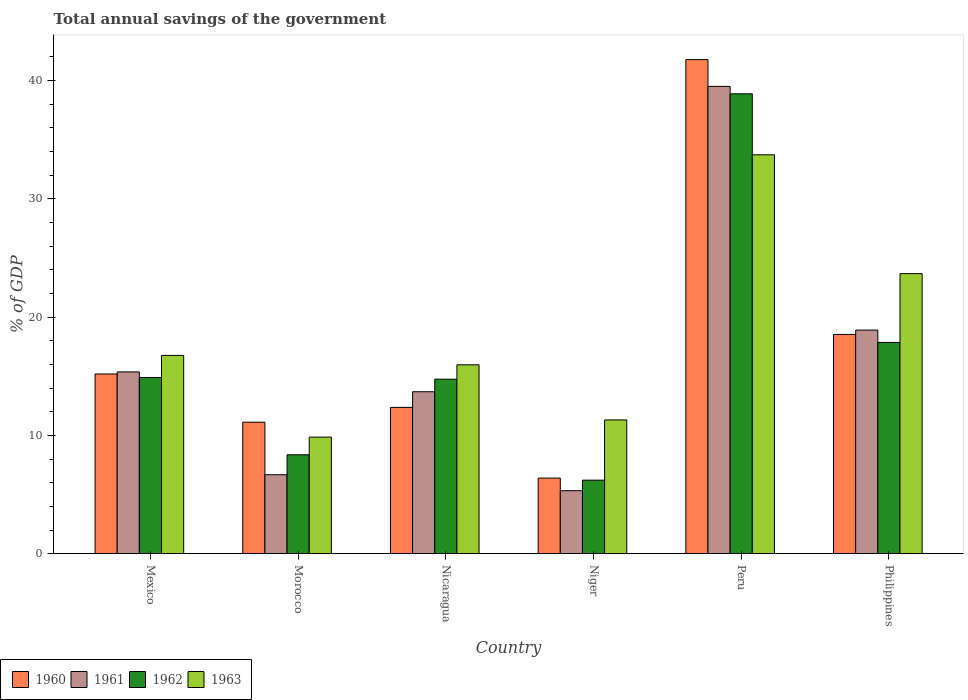How many different coloured bars are there?
Keep it short and to the point. 4. How many groups of bars are there?
Your response must be concise. 6. Are the number of bars per tick equal to the number of legend labels?
Ensure brevity in your answer.  Yes. Are the number of bars on each tick of the X-axis equal?
Ensure brevity in your answer.  Yes. How many bars are there on the 2nd tick from the left?
Offer a terse response. 4. How many bars are there on the 1st tick from the right?
Offer a very short reply. 4. What is the total annual savings of the government in 1961 in Niger?
Your answer should be compact. 5.32. Across all countries, what is the maximum total annual savings of the government in 1961?
Give a very brief answer. 39.51. Across all countries, what is the minimum total annual savings of the government in 1963?
Your answer should be very brief. 9.85. In which country was the total annual savings of the government in 1962 minimum?
Keep it short and to the point. Niger. What is the total total annual savings of the government in 1962 in the graph?
Your response must be concise. 100.96. What is the difference between the total annual savings of the government in 1962 in Nicaragua and that in Niger?
Give a very brief answer. 8.54. What is the difference between the total annual savings of the government in 1963 in Mexico and the total annual savings of the government in 1961 in Philippines?
Give a very brief answer. -2.14. What is the average total annual savings of the government in 1962 per country?
Provide a short and direct response. 16.83. What is the difference between the total annual savings of the government of/in 1960 and total annual savings of the government of/in 1963 in Nicaragua?
Keep it short and to the point. -3.6. What is the ratio of the total annual savings of the government in 1961 in Nicaragua to that in Philippines?
Offer a terse response. 0.72. What is the difference between the highest and the second highest total annual savings of the government in 1961?
Give a very brief answer. 3.54. What is the difference between the highest and the lowest total annual savings of the government in 1963?
Provide a short and direct response. 23.87. Is it the case that in every country, the sum of the total annual savings of the government in 1961 and total annual savings of the government in 1962 is greater than the sum of total annual savings of the government in 1963 and total annual savings of the government in 1960?
Your answer should be very brief. No. What does the 2nd bar from the left in Peru represents?
Your response must be concise. 1961. Is it the case that in every country, the sum of the total annual savings of the government in 1961 and total annual savings of the government in 1960 is greater than the total annual savings of the government in 1963?
Keep it short and to the point. Yes. How many countries are there in the graph?
Your response must be concise. 6. Where does the legend appear in the graph?
Keep it short and to the point. Bottom left. How many legend labels are there?
Ensure brevity in your answer.  4. What is the title of the graph?
Offer a very short reply. Total annual savings of the government. What is the label or title of the Y-axis?
Provide a short and direct response. % of GDP. What is the % of GDP in 1960 in Mexico?
Keep it short and to the point. 15.19. What is the % of GDP of 1961 in Mexico?
Ensure brevity in your answer.  15.37. What is the % of GDP in 1962 in Mexico?
Keep it short and to the point. 14.89. What is the % of GDP of 1963 in Mexico?
Offer a very short reply. 16.76. What is the % of GDP in 1960 in Morocco?
Ensure brevity in your answer.  11.12. What is the % of GDP of 1961 in Morocco?
Give a very brief answer. 6.67. What is the % of GDP in 1962 in Morocco?
Your answer should be very brief. 8.36. What is the % of GDP in 1963 in Morocco?
Provide a succinct answer. 9.85. What is the % of GDP in 1960 in Nicaragua?
Provide a short and direct response. 12.37. What is the % of GDP in 1961 in Nicaragua?
Your response must be concise. 13.69. What is the % of GDP in 1962 in Nicaragua?
Provide a succinct answer. 14.75. What is the % of GDP of 1963 in Nicaragua?
Your response must be concise. 15.97. What is the % of GDP in 1960 in Niger?
Keep it short and to the point. 6.39. What is the % of GDP in 1961 in Niger?
Your response must be concise. 5.32. What is the % of GDP in 1962 in Niger?
Your response must be concise. 6.21. What is the % of GDP in 1963 in Niger?
Keep it short and to the point. 11.31. What is the % of GDP of 1960 in Peru?
Offer a terse response. 41.78. What is the % of GDP of 1961 in Peru?
Keep it short and to the point. 39.51. What is the % of GDP of 1962 in Peru?
Give a very brief answer. 38.88. What is the % of GDP in 1963 in Peru?
Make the answer very short. 33.73. What is the % of GDP of 1960 in Philippines?
Provide a short and direct response. 18.54. What is the % of GDP in 1961 in Philippines?
Your answer should be compact. 18.9. What is the % of GDP of 1962 in Philippines?
Offer a terse response. 17.86. What is the % of GDP in 1963 in Philippines?
Provide a short and direct response. 23.68. Across all countries, what is the maximum % of GDP of 1960?
Provide a short and direct response. 41.78. Across all countries, what is the maximum % of GDP in 1961?
Give a very brief answer. 39.51. Across all countries, what is the maximum % of GDP in 1962?
Your answer should be very brief. 38.88. Across all countries, what is the maximum % of GDP of 1963?
Offer a very short reply. 33.73. Across all countries, what is the minimum % of GDP of 1960?
Your response must be concise. 6.39. Across all countries, what is the minimum % of GDP in 1961?
Offer a very short reply. 5.32. Across all countries, what is the minimum % of GDP in 1962?
Offer a terse response. 6.21. Across all countries, what is the minimum % of GDP in 1963?
Your answer should be very brief. 9.85. What is the total % of GDP of 1960 in the graph?
Make the answer very short. 105.38. What is the total % of GDP of 1961 in the graph?
Offer a terse response. 99.46. What is the total % of GDP in 1962 in the graph?
Keep it short and to the point. 100.96. What is the total % of GDP in 1963 in the graph?
Provide a succinct answer. 111.3. What is the difference between the % of GDP of 1960 in Mexico and that in Morocco?
Your answer should be very brief. 4.08. What is the difference between the % of GDP in 1961 in Mexico and that in Morocco?
Your answer should be very brief. 8.7. What is the difference between the % of GDP in 1962 in Mexico and that in Morocco?
Provide a short and direct response. 6.53. What is the difference between the % of GDP of 1963 in Mexico and that in Morocco?
Ensure brevity in your answer.  6.91. What is the difference between the % of GDP in 1960 in Mexico and that in Nicaragua?
Your answer should be compact. 2.82. What is the difference between the % of GDP in 1961 in Mexico and that in Nicaragua?
Your answer should be very brief. 1.68. What is the difference between the % of GDP of 1962 in Mexico and that in Nicaragua?
Offer a very short reply. 0.14. What is the difference between the % of GDP of 1963 in Mexico and that in Nicaragua?
Keep it short and to the point. 0.8. What is the difference between the % of GDP in 1960 in Mexico and that in Niger?
Offer a very short reply. 8.8. What is the difference between the % of GDP of 1961 in Mexico and that in Niger?
Ensure brevity in your answer.  10.04. What is the difference between the % of GDP of 1962 in Mexico and that in Niger?
Offer a very short reply. 8.68. What is the difference between the % of GDP in 1963 in Mexico and that in Niger?
Offer a very short reply. 5.46. What is the difference between the % of GDP in 1960 in Mexico and that in Peru?
Offer a very short reply. -26.58. What is the difference between the % of GDP of 1961 in Mexico and that in Peru?
Offer a very short reply. -24.14. What is the difference between the % of GDP in 1962 in Mexico and that in Peru?
Your response must be concise. -23.99. What is the difference between the % of GDP in 1963 in Mexico and that in Peru?
Make the answer very short. -16.96. What is the difference between the % of GDP in 1960 in Mexico and that in Philippines?
Your answer should be compact. -3.34. What is the difference between the % of GDP in 1961 in Mexico and that in Philippines?
Provide a succinct answer. -3.54. What is the difference between the % of GDP in 1962 in Mexico and that in Philippines?
Provide a short and direct response. -2.97. What is the difference between the % of GDP in 1963 in Mexico and that in Philippines?
Give a very brief answer. -6.92. What is the difference between the % of GDP in 1960 in Morocco and that in Nicaragua?
Offer a terse response. -1.25. What is the difference between the % of GDP of 1961 in Morocco and that in Nicaragua?
Give a very brief answer. -7.02. What is the difference between the % of GDP of 1962 in Morocco and that in Nicaragua?
Your answer should be compact. -6.39. What is the difference between the % of GDP of 1963 in Morocco and that in Nicaragua?
Your answer should be very brief. -6.11. What is the difference between the % of GDP in 1960 in Morocco and that in Niger?
Keep it short and to the point. 4.73. What is the difference between the % of GDP of 1961 in Morocco and that in Niger?
Offer a terse response. 1.35. What is the difference between the % of GDP of 1962 in Morocco and that in Niger?
Your response must be concise. 2.15. What is the difference between the % of GDP in 1963 in Morocco and that in Niger?
Keep it short and to the point. -1.45. What is the difference between the % of GDP of 1960 in Morocco and that in Peru?
Keep it short and to the point. -30.66. What is the difference between the % of GDP in 1961 in Morocco and that in Peru?
Your response must be concise. -32.84. What is the difference between the % of GDP of 1962 in Morocco and that in Peru?
Give a very brief answer. -30.52. What is the difference between the % of GDP of 1963 in Morocco and that in Peru?
Provide a short and direct response. -23.87. What is the difference between the % of GDP of 1960 in Morocco and that in Philippines?
Provide a succinct answer. -7.42. What is the difference between the % of GDP in 1961 in Morocco and that in Philippines?
Give a very brief answer. -12.23. What is the difference between the % of GDP in 1962 in Morocco and that in Philippines?
Make the answer very short. -9.5. What is the difference between the % of GDP of 1963 in Morocco and that in Philippines?
Your answer should be very brief. -13.82. What is the difference between the % of GDP in 1960 in Nicaragua and that in Niger?
Your answer should be very brief. 5.98. What is the difference between the % of GDP of 1961 in Nicaragua and that in Niger?
Keep it short and to the point. 8.37. What is the difference between the % of GDP of 1962 in Nicaragua and that in Niger?
Keep it short and to the point. 8.54. What is the difference between the % of GDP in 1963 in Nicaragua and that in Niger?
Your answer should be compact. 4.66. What is the difference between the % of GDP of 1960 in Nicaragua and that in Peru?
Make the answer very short. -29.41. What is the difference between the % of GDP of 1961 in Nicaragua and that in Peru?
Keep it short and to the point. -25.82. What is the difference between the % of GDP of 1962 in Nicaragua and that in Peru?
Ensure brevity in your answer.  -24.13. What is the difference between the % of GDP in 1963 in Nicaragua and that in Peru?
Offer a very short reply. -17.76. What is the difference between the % of GDP of 1960 in Nicaragua and that in Philippines?
Ensure brevity in your answer.  -6.17. What is the difference between the % of GDP in 1961 in Nicaragua and that in Philippines?
Keep it short and to the point. -5.21. What is the difference between the % of GDP of 1962 in Nicaragua and that in Philippines?
Offer a terse response. -3.11. What is the difference between the % of GDP of 1963 in Nicaragua and that in Philippines?
Offer a terse response. -7.71. What is the difference between the % of GDP of 1960 in Niger and that in Peru?
Provide a succinct answer. -35.38. What is the difference between the % of GDP in 1961 in Niger and that in Peru?
Offer a terse response. -34.18. What is the difference between the % of GDP in 1962 in Niger and that in Peru?
Provide a succinct answer. -32.67. What is the difference between the % of GDP of 1963 in Niger and that in Peru?
Give a very brief answer. -22.42. What is the difference between the % of GDP of 1960 in Niger and that in Philippines?
Ensure brevity in your answer.  -12.15. What is the difference between the % of GDP of 1961 in Niger and that in Philippines?
Keep it short and to the point. -13.58. What is the difference between the % of GDP of 1962 in Niger and that in Philippines?
Provide a short and direct response. -11.65. What is the difference between the % of GDP of 1963 in Niger and that in Philippines?
Provide a short and direct response. -12.37. What is the difference between the % of GDP of 1960 in Peru and that in Philippines?
Your answer should be very brief. 23.24. What is the difference between the % of GDP in 1961 in Peru and that in Philippines?
Offer a very short reply. 20.6. What is the difference between the % of GDP of 1962 in Peru and that in Philippines?
Keep it short and to the point. 21.02. What is the difference between the % of GDP of 1963 in Peru and that in Philippines?
Make the answer very short. 10.05. What is the difference between the % of GDP of 1960 in Mexico and the % of GDP of 1961 in Morocco?
Provide a succinct answer. 8.52. What is the difference between the % of GDP in 1960 in Mexico and the % of GDP in 1962 in Morocco?
Keep it short and to the point. 6.83. What is the difference between the % of GDP in 1960 in Mexico and the % of GDP in 1963 in Morocco?
Offer a terse response. 5.34. What is the difference between the % of GDP of 1961 in Mexico and the % of GDP of 1962 in Morocco?
Your response must be concise. 7.01. What is the difference between the % of GDP in 1961 in Mexico and the % of GDP in 1963 in Morocco?
Provide a succinct answer. 5.51. What is the difference between the % of GDP in 1962 in Mexico and the % of GDP in 1963 in Morocco?
Your answer should be compact. 5.04. What is the difference between the % of GDP of 1960 in Mexico and the % of GDP of 1961 in Nicaragua?
Offer a very short reply. 1.5. What is the difference between the % of GDP of 1960 in Mexico and the % of GDP of 1962 in Nicaragua?
Offer a terse response. 0.44. What is the difference between the % of GDP of 1960 in Mexico and the % of GDP of 1963 in Nicaragua?
Your answer should be compact. -0.78. What is the difference between the % of GDP of 1961 in Mexico and the % of GDP of 1962 in Nicaragua?
Your answer should be very brief. 0.62. What is the difference between the % of GDP of 1961 in Mexico and the % of GDP of 1963 in Nicaragua?
Give a very brief answer. -0.6. What is the difference between the % of GDP of 1962 in Mexico and the % of GDP of 1963 in Nicaragua?
Make the answer very short. -1.07. What is the difference between the % of GDP of 1960 in Mexico and the % of GDP of 1961 in Niger?
Give a very brief answer. 9.87. What is the difference between the % of GDP of 1960 in Mexico and the % of GDP of 1962 in Niger?
Provide a succinct answer. 8.98. What is the difference between the % of GDP in 1960 in Mexico and the % of GDP in 1963 in Niger?
Offer a very short reply. 3.89. What is the difference between the % of GDP in 1961 in Mexico and the % of GDP in 1962 in Niger?
Give a very brief answer. 9.16. What is the difference between the % of GDP in 1961 in Mexico and the % of GDP in 1963 in Niger?
Provide a short and direct response. 4.06. What is the difference between the % of GDP of 1962 in Mexico and the % of GDP of 1963 in Niger?
Give a very brief answer. 3.59. What is the difference between the % of GDP in 1960 in Mexico and the % of GDP in 1961 in Peru?
Ensure brevity in your answer.  -24.32. What is the difference between the % of GDP of 1960 in Mexico and the % of GDP of 1962 in Peru?
Give a very brief answer. -23.69. What is the difference between the % of GDP of 1960 in Mexico and the % of GDP of 1963 in Peru?
Offer a very short reply. -18.53. What is the difference between the % of GDP of 1961 in Mexico and the % of GDP of 1962 in Peru?
Your answer should be very brief. -23.51. What is the difference between the % of GDP in 1961 in Mexico and the % of GDP in 1963 in Peru?
Ensure brevity in your answer.  -18.36. What is the difference between the % of GDP in 1962 in Mexico and the % of GDP in 1963 in Peru?
Provide a succinct answer. -18.83. What is the difference between the % of GDP of 1960 in Mexico and the % of GDP of 1961 in Philippines?
Your response must be concise. -3.71. What is the difference between the % of GDP in 1960 in Mexico and the % of GDP in 1962 in Philippines?
Give a very brief answer. -2.67. What is the difference between the % of GDP in 1960 in Mexico and the % of GDP in 1963 in Philippines?
Give a very brief answer. -8.49. What is the difference between the % of GDP of 1961 in Mexico and the % of GDP of 1962 in Philippines?
Offer a very short reply. -2.49. What is the difference between the % of GDP in 1961 in Mexico and the % of GDP in 1963 in Philippines?
Your answer should be compact. -8.31. What is the difference between the % of GDP in 1962 in Mexico and the % of GDP in 1963 in Philippines?
Your answer should be compact. -8.78. What is the difference between the % of GDP in 1960 in Morocco and the % of GDP in 1961 in Nicaragua?
Provide a succinct answer. -2.57. What is the difference between the % of GDP in 1960 in Morocco and the % of GDP in 1962 in Nicaragua?
Provide a short and direct response. -3.63. What is the difference between the % of GDP in 1960 in Morocco and the % of GDP in 1963 in Nicaragua?
Offer a very short reply. -4.85. What is the difference between the % of GDP of 1961 in Morocco and the % of GDP of 1962 in Nicaragua?
Offer a terse response. -8.08. What is the difference between the % of GDP of 1961 in Morocco and the % of GDP of 1963 in Nicaragua?
Your answer should be very brief. -9.3. What is the difference between the % of GDP in 1962 in Morocco and the % of GDP in 1963 in Nicaragua?
Your answer should be very brief. -7.61. What is the difference between the % of GDP of 1960 in Morocco and the % of GDP of 1961 in Niger?
Offer a very short reply. 5.79. What is the difference between the % of GDP in 1960 in Morocco and the % of GDP in 1962 in Niger?
Provide a succinct answer. 4.9. What is the difference between the % of GDP of 1960 in Morocco and the % of GDP of 1963 in Niger?
Make the answer very short. -0.19. What is the difference between the % of GDP in 1961 in Morocco and the % of GDP in 1962 in Niger?
Offer a very short reply. 0.46. What is the difference between the % of GDP in 1961 in Morocco and the % of GDP in 1963 in Niger?
Provide a succinct answer. -4.63. What is the difference between the % of GDP of 1962 in Morocco and the % of GDP of 1963 in Niger?
Provide a succinct answer. -2.94. What is the difference between the % of GDP of 1960 in Morocco and the % of GDP of 1961 in Peru?
Offer a terse response. -28.39. What is the difference between the % of GDP in 1960 in Morocco and the % of GDP in 1962 in Peru?
Provide a short and direct response. -27.76. What is the difference between the % of GDP in 1960 in Morocco and the % of GDP in 1963 in Peru?
Your response must be concise. -22.61. What is the difference between the % of GDP in 1961 in Morocco and the % of GDP in 1962 in Peru?
Offer a very short reply. -32.21. What is the difference between the % of GDP of 1961 in Morocco and the % of GDP of 1963 in Peru?
Give a very brief answer. -27.05. What is the difference between the % of GDP in 1962 in Morocco and the % of GDP in 1963 in Peru?
Your answer should be compact. -25.36. What is the difference between the % of GDP in 1960 in Morocco and the % of GDP in 1961 in Philippines?
Provide a short and direct response. -7.79. What is the difference between the % of GDP of 1960 in Morocco and the % of GDP of 1962 in Philippines?
Your answer should be very brief. -6.75. What is the difference between the % of GDP of 1960 in Morocco and the % of GDP of 1963 in Philippines?
Make the answer very short. -12.56. What is the difference between the % of GDP of 1961 in Morocco and the % of GDP of 1962 in Philippines?
Give a very brief answer. -11.19. What is the difference between the % of GDP in 1961 in Morocco and the % of GDP in 1963 in Philippines?
Your answer should be very brief. -17.01. What is the difference between the % of GDP in 1962 in Morocco and the % of GDP in 1963 in Philippines?
Your response must be concise. -15.32. What is the difference between the % of GDP in 1960 in Nicaragua and the % of GDP in 1961 in Niger?
Your answer should be compact. 7.04. What is the difference between the % of GDP of 1960 in Nicaragua and the % of GDP of 1962 in Niger?
Your answer should be compact. 6.16. What is the difference between the % of GDP of 1960 in Nicaragua and the % of GDP of 1963 in Niger?
Make the answer very short. 1.06. What is the difference between the % of GDP in 1961 in Nicaragua and the % of GDP in 1962 in Niger?
Offer a terse response. 7.48. What is the difference between the % of GDP in 1961 in Nicaragua and the % of GDP in 1963 in Niger?
Your response must be concise. 2.38. What is the difference between the % of GDP of 1962 in Nicaragua and the % of GDP of 1963 in Niger?
Ensure brevity in your answer.  3.45. What is the difference between the % of GDP in 1960 in Nicaragua and the % of GDP in 1961 in Peru?
Offer a terse response. -27.14. What is the difference between the % of GDP of 1960 in Nicaragua and the % of GDP of 1962 in Peru?
Your response must be concise. -26.51. What is the difference between the % of GDP in 1960 in Nicaragua and the % of GDP in 1963 in Peru?
Offer a very short reply. -21.36. What is the difference between the % of GDP in 1961 in Nicaragua and the % of GDP in 1962 in Peru?
Give a very brief answer. -25.19. What is the difference between the % of GDP of 1961 in Nicaragua and the % of GDP of 1963 in Peru?
Give a very brief answer. -20.04. What is the difference between the % of GDP in 1962 in Nicaragua and the % of GDP in 1963 in Peru?
Provide a succinct answer. -18.97. What is the difference between the % of GDP of 1960 in Nicaragua and the % of GDP of 1961 in Philippines?
Your answer should be compact. -6.54. What is the difference between the % of GDP of 1960 in Nicaragua and the % of GDP of 1962 in Philippines?
Keep it short and to the point. -5.49. What is the difference between the % of GDP of 1960 in Nicaragua and the % of GDP of 1963 in Philippines?
Your response must be concise. -11.31. What is the difference between the % of GDP in 1961 in Nicaragua and the % of GDP in 1962 in Philippines?
Provide a succinct answer. -4.17. What is the difference between the % of GDP in 1961 in Nicaragua and the % of GDP in 1963 in Philippines?
Make the answer very short. -9.99. What is the difference between the % of GDP of 1962 in Nicaragua and the % of GDP of 1963 in Philippines?
Your response must be concise. -8.93. What is the difference between the % of GDP in 1960 in Niger and the % of GDP in 1961 in Peru?
Offer a terse response. -33.12. What is the difference between the % of GDP in 1960 in Niger and the % of GDP in 1962 in Peru?
Provide a short and direct response. -32.49. What is the difference between the % of GDP in 1960 in Niger and the % of GDP in 1963 in Peru?
Your answer should be compact. -27.33. What is the difference between the % of GDP in 1961 in Niger and the % of GDP in 1962 in Peru?
Offer a very short reply. -33.56. What is the difference between the % of GDP in 1961 in Niger and the % of GDP in 1963 in Peru?
Provide a succinct answer. -28.4. What is the difference between the % of GDP of 1962 in Niger and the % of GDP of 1963 in Peru?
Your response must be concise. -27.51. What is the difference between the % of GDP of 1960 in Niger and the % of GDP of 1961 in Philippines?
Your answer should be very brief. -12.51. What is the difference between the % of GDP in 1960 in Niger and the % of GDP in 1962 in Philippines?
Keep it short and to the point. -11.47. What is the difference between the % of GDP of 1960 in Niger and the % of GDP of 1963 in Philippines?
Provide a short and direct response. -17.29. What is the difference between the % of GDP in 1961 in Niger and the % of GDP in 1962 in Philippines?
Offer a terse response. -12.54. What is the difference between the % of GDP of 1961 in Niger and the % of GDP of 1963 in Philippines?
Provide a short and direct response. -18.35. What is the difference between the % of GDP of 1962 in Niger and the % of GDP of 1963 in Philippines?
Your answer should be very brief. -17.47. What is the difference between the % of GDP of 1960 in Peru and the % of GDP of 1961 in Philippines?
Your response must be concise. 22.87. What is the difference between the % of GDP in 1960 in Peru and the % of GDP in 1962 in Philippines?
Offer a very short reply. 23.91. What is the difference between the % of GDP of 1960 in Peru and the % of GDP of 1963 in Philippines?
Keep it short and to the point. 18.1. What is the difference between the % of GDP in 1961 in Peru and the % of GDP in 1962 in Philippines?
Offer a terse response. 21.65. What is the difference between the % of GDP in 1961 in Peru and the % of GDP in 1963 in Philippines?
Offer a terse response. 15.83. What is the difference between the % of GDP in 1962 in Peru and the % of GDP in 1963 in Philippines?
Your answer should be compact. 15.2. What is the average % of GDP in 1960 per country?
Make the answer very short. 17.56. What is the average % of GDP in 1961 per country?
Ensure brevity in your answer.  16.58. What is the average % of GDP of 1962 per country?
Provide a short and direct response. 16.83. What is the average % of GDP of 1963 per country?
Offer a terse response. 18.55. What is the difference between the % of GDP of 1960 and % of GDP of 1961 in Mexico?
Keep it short and to the point. -0.18. What is the difference between the % of GDP of 1960 and % of GDP of 1962 in Mexico?
Your answer should be compact. 0.3. What is the difference between the % of GDP of 1960 and % of GDP of 1963 in Mexico?
Give a very brief answer. -1.57. What is the difference between the % of GDP of 1961 and % of GDP of 1962 in Mexico?
Provide a succinct answer. 0.47. What is the difference between the % of GDP in 1961 and % of GDP in 1963 in Mexico?
Provide a succinct answer. -1.4. What is the difference between the % of GDP in 1962 and % of GDP in 1963 in Mexico?
Your answer should be compact. -1.87. What is the difference between the % of GDP in 1960 and % of GDP in 1961 in Morocco?
Keep it short and to the point. 4.45. What is the difference between the % of GDP of 1960 and % of GDP of 1962 in Morocco?
Provide a short and direct response. 2.75. What is the difference between the % of GDP in 1960 and % of GDP in 1963 in Morocco?
Provide a succinct answer. 1.26. What is the difference between the % of GDP of 1961 and % of GDP of 1962 in Morocco?
Provide a short and direct response. -1.69. What is the difference between the % of GDP in 1961 and % of GDP in 1963 in Morocco?
Your response must be concise. -3.18. What is the difference between the % of GDP in 1962 and % of GDP in 1963 in Morocco?
Your answer should be compact. -1.49. What is the difference between the % of GDP of 1960 and % of GDP of 1961 in Nicaragua?
Give a very brief answer. -1.32. What is the difference between the % of GDP of 1960 and % of GDP of 1962 in Nicaragua?
Keep it short and to the point. -2.38. What is the difference between the % of GDP of 1960 and % of GDP of 1963 in Nicaragua?
Ensure brevity in your answer.  -3.6. What is the difference between the % of GDP in 1961 and % of GDP in 1962 in Nicaragua?
Your answer should be compact. -1.06. What is the difference between the % of GDP in 1961 and % of GDP in 1963 in Nicaragua?
Your answer should be very brief. -2.28. What is the difference between the % of GDP of 1962 and % of GDP of 1963 in Nicaragua?
Your answer should be compact. -1.22. What is the difference between the % of GDP in 1960 and % of GDP in 1961 in Niger?
Make the answer very short. 1.07. What is the difference between the % of GDP of 1960 and % of GDP of 1962 in Niger?
Provide a succinct answer. 0.18. What is the difference between the % of GDP of 1960 and % of GDP of 1963 in Niger?
Make the answer very short. -4.91. What is the difference between the % of GDP of 1961 and % of GDP of 1962 in Niger?
Provide a short and direct response. -0.89. What is the difference between the % of GDP of 1961 and % of GDP of 1963 in Niger?
Give a very brief answer. -5.98. What is the difference between the % of GDP in 1962 and % of GDP in 1963 in Niger?
Your answer should be very brief. -5.09. What is the difference between the % of GDP of 1960 and % of GDP of 1961 in Peru?
Give a very brief answer. 2.27. What is the difference between the % of GDP in 1960 and % of GDP in 1962 in Peru?
Your answer should be compact. 2.89. What is the difference between the % of GDP in 1960 and % of GDP in 1963 in Peru?
Your answer should be very brief. 8.05. What is the difference between the % of GDP in 1961 and % of GDP in 1962 in Peru?
Keep it short and to the point. 0.63. What is the difference between the % of GDP of 1961 and % of GDP of 1963 in Peru?
Give a very brief answer. 5.78. What is the difference between the % of GDP of 1962 and % of GDP of 1963 in Peru?
Ensure brevity in your answer.  5.16. What is the difference between the % of GDP in 1960 and % of GDP in 1961 in Philippines?
Keep it short and to the point. -0.37. What is the difference between the % of GDP in 1960 and % of GDP in 1962 in Philippines?
Your answer should be compact. 0.67. What is the difference between the % of GDP in 1960 and % of GDP in 1963 in Philippines?
Your answer should be compact. -5.14. What is the difference between the % of GDP in 1961 and % of GDP in 1962 in Philippines?
Your answer should be very brief. 1.04. What is the difference between the % of GDP of 1961 and % of GDP of 1963 in Philippines?
Ensure brevity in your answer.  -4.78. What is the difference between the % of GDP of 1962 and % of GDP of 1963 in Philippines?
Offer a very short reply. -5.82. What is the ratio of the % of GDP of 1960 in Mexico to that in Morocco?
Your answer should be compact. 1.37. What is the ratio of the % of GDP in 1961 in Mexico to that in Morocco?
Your answer should be very brief. 2.3. What is the ratio of the % of GDP of 1962 in Mexico to that in Morocco?
Make the answer very short. 1.78. What is the ratio of the % of GDP in 1963 in Mexico to that in Morocco?
Your answer should be compact. 1.7. What is the ratio of the % of GDP in 1960 in Mexico to that in Nicaragua?
Offer a terse response. 1.23. What is the ratio of the % of GDP of 1961 in Mexico to that in Nicaragua?
Keep it short and to the point. 1.12. What is the ratio of the % of GDP of 1962 in Mexico to that in Nicaragua?
Keep it short and to the point. 1.01. What is the ratio of the % of GDP of 1963 in Mexico to that in Nicaragua?
Keep it short and to the point. 1.05. What is the ratio of the % of GDP in 1960 in Mexico to that in Niger?
Give a very brief answer. 2.38. What is the ratio of the % of GDP in 1961 in Mexico to that in Niger?
Your answer should be compact. 2.89. What is the ratio of the % of GDP in 1962 in Mexico to that in Niger?
Your response must be concise. 2.4. What is the ratio of the % of GDP of 1963 in Mexico to that in Niger?
Provide a short and direct response. 1.48. What is the ratio of the % of GDP in 1960 in Mexico to that in Peru?
Make the answer very short. 0.36. What is the ratio of the % of GDP in 1961 in Mexico to that in Peru?
Your response must be concise. 0.39. What is the ratio of the % of GDP in 1962 in Mexico to that in Peru?
Your response must be concise. 0.38. What is the ratio of the % of GDP of 1963 in Mexico to that in Peru?
Offer a very short reply. 0.5. What is the ratio of the % of GDP of 1960 in Mexico to that in Philippines?
Offer a very short reply. 0.82. What is the ratio of the % of GDP of 1961 in Mexico to that in Philippines?
Your answer should be very brief. 0.81. What is the ratio of the % of GDP of 1962 in Mexico to that in Philippines?
Offer a very short reply. 0.83. What is the ratio of the % of GDP in 1963 in Mexico to that in Philippines?
Make the answer very short. 0.71. What is the ratio of the % of GDP in 1960 in Morocco to that in Nicaragua?
Make the answer very short. 0.9. What is the ratio of the % of GDP in 1961 in Morocco to that in Nicaragua?
Provide a succinct answer. 0.49. What is the ratio of the % of GDP in 1962 in Morocco to that in Nicaragua?
Offer a very short reply. 0.57. What is the ratio of the % of GDP of 1963 in Morocco to that in Nicaragua?
Provide a succinct answer. 0.62. What is the ratio of the % of GDP in 1960 in Morocco to that in Niger?
Your answer should be very brief. 1.74. What is the ratio of the % of GDP in 1961 in Morocco to that in Niger?
Make the answer very short. 1.25. What is the ratio of the % of GDP in 1962 in Morocco to that in Niger?
Offer a very short reply. 1.35. What is the ratio of the % of GDP in 1963 in Morocco to that in Niger?
Ensure brevity in your answer.  0.87. What is the ratio of the % of GDP of 1960 in Morocco to that in Peru?
Offer a very short reply. 0.27. What is the ratio of the % of GDP in 1961 in Morocco to that in Peru?
Ensure brevity in your answer.  0.17. What is the ratio of the % of GDP of 1962 in Morocco to that in Peru?
Your answer should be compact. 0.22. What is the ratio of the % of GDP of 1963 in Morocco to that in Peru?
Offer a very short reply. 0.29. What is the ratio of the % of GDP of 1960 in Morocco to that in Philippines?
Your answer should be very brief. 0.6. What is the ratio of the % of GDP in 1961 in Morocco to that in Philippines?
Your answer should be compact. 0.35. What is the ratio of the % of GDP in 1962 in Morocco to that in Philippines?
Keep it short and to the point. 0.47. What is the ratio of the % of GDP of 1963 in Morocco to that in Philippines?
Your answer should be compact. 0.42. What is the ratio of the % of GDP in 1960 in Nicaragua to that in Niger?
Ensure brevity in your answer.  1.94. What is the ratio of the % of GDP of 1961 in Nicaragua to that in Niger?
Your response must be concise. 2.57. What is the ratio of the % of GDP of 1962 in Nicaragua to that in Niger?
Provide a succinct answer. 2.37. What is the ratio of the % of GDP in 1963 in Nicaragua to that in Niger?
Give a very brief answer. 1.41. What is the ratio of the % of GDP in 1960 in Nicaragua to that in Peru?
Provide a succinct answer. 0.3. What is the ratio of the % of GDP in 1961 in Nicaragua to that in Peru?
Ensure brevity in your answer.  0.35. What is the ratio of the % of GDP of 1962 in Nicaragua to that in Peru?
Offer a very short reply. 0.38. What is the ratio of the % of GDP in 1963 in Nicaragua to that in Peru?
Provide a short and direct response. 0.47. What is the ratio of the % of GDP of 1960 in Nicaragua to that in Philippines?
Offer a very short reply. 0.67. What is the ratio of the % of GDP in 1961 in Nicaragua to that in Philippines?
Make the answer very short. 0.72. What is the ratio of the % of GDP of 1962 in Nicaragua to that in Philippines?
Provide a succinct answer. 0.83. What is the ratio of the % of GDP in 1963 in Nicaragua to that in Philippines?
Ensure brevity in your answer.  0.67. What is the ratio of the % of GDP of 1960 in Niger to that in Peru?
Keep it short and to the point. 0.15. What is the ratio of the % of GDP in 1961 in Niger to that in Peru?
Provide a short and direct response. 0.13. What is the ratio of the % of GDP of 1962 in Niger to that in Peru?
Offer a very short reply. 0.16. What is the ratio of the % of GDP of 1963 in Niger to that in Peru?
Give a very brief answer. 0.34. What is the ratio of the % of GDP in 1960 in Niger to that in Philippines?
Make the answer very short. 0.34. What is the ratio of the % of GDP of 1961 in Niger to that in Philippines?
Offer a very short reply. 0.28. What is the ratio of the % of GDP in 1962 in Niger to that in Philippines?
Provide a succinct answer. 0.35. What is the ratio of the % of GDP of 1963 in Niger to that in Philippines?
Offer a very short reply. 0.48. What is the ratio of the % of GDP of 1960 in Peru to that in Philippines?
Offer a very short reply. 2.25. What is the ratio of the % of GDP of 1961 in Peru to that in Philippines?
Ensure brevity in your answer.  2.09. What is the ratio of the % of GDP in 1962 in Peru to that in Philippines?
Offer a terse response. 2.18. What is the ratio of the % of GDP of 1963 in Peru to that in Philippines?
Your answer should be very brief. 1.42. What is the difference between the highest and the second highest % of GDP of 1960?
Your answer should be compact. 23.24. What is the difference between the highest and the second highest % of GDP in 1961?
Provide a short and direct response. 20.6. What is the difference between the highest and the second highest % of GDP of 1962?
Offer a very short reply. 21.02. What is the difference between the highest and the second highest % of GDP in 1963?
Keep it short and to the point. 10.05. What is the difference between the highest and the lowest % of GDP of 1960?
Your response must be concise. 35.38. What is the difference between the highest and the lowest % of GDP in 1961?
Your answer should be compact. 34.18. What is the difference between the highest and the lowest % of GDP of 1962?
Provide a succinct answer. 32.67. What is the difference between the highest and the lowest % of GDP in 1963?
Keep it short and to the point. 23.87. 